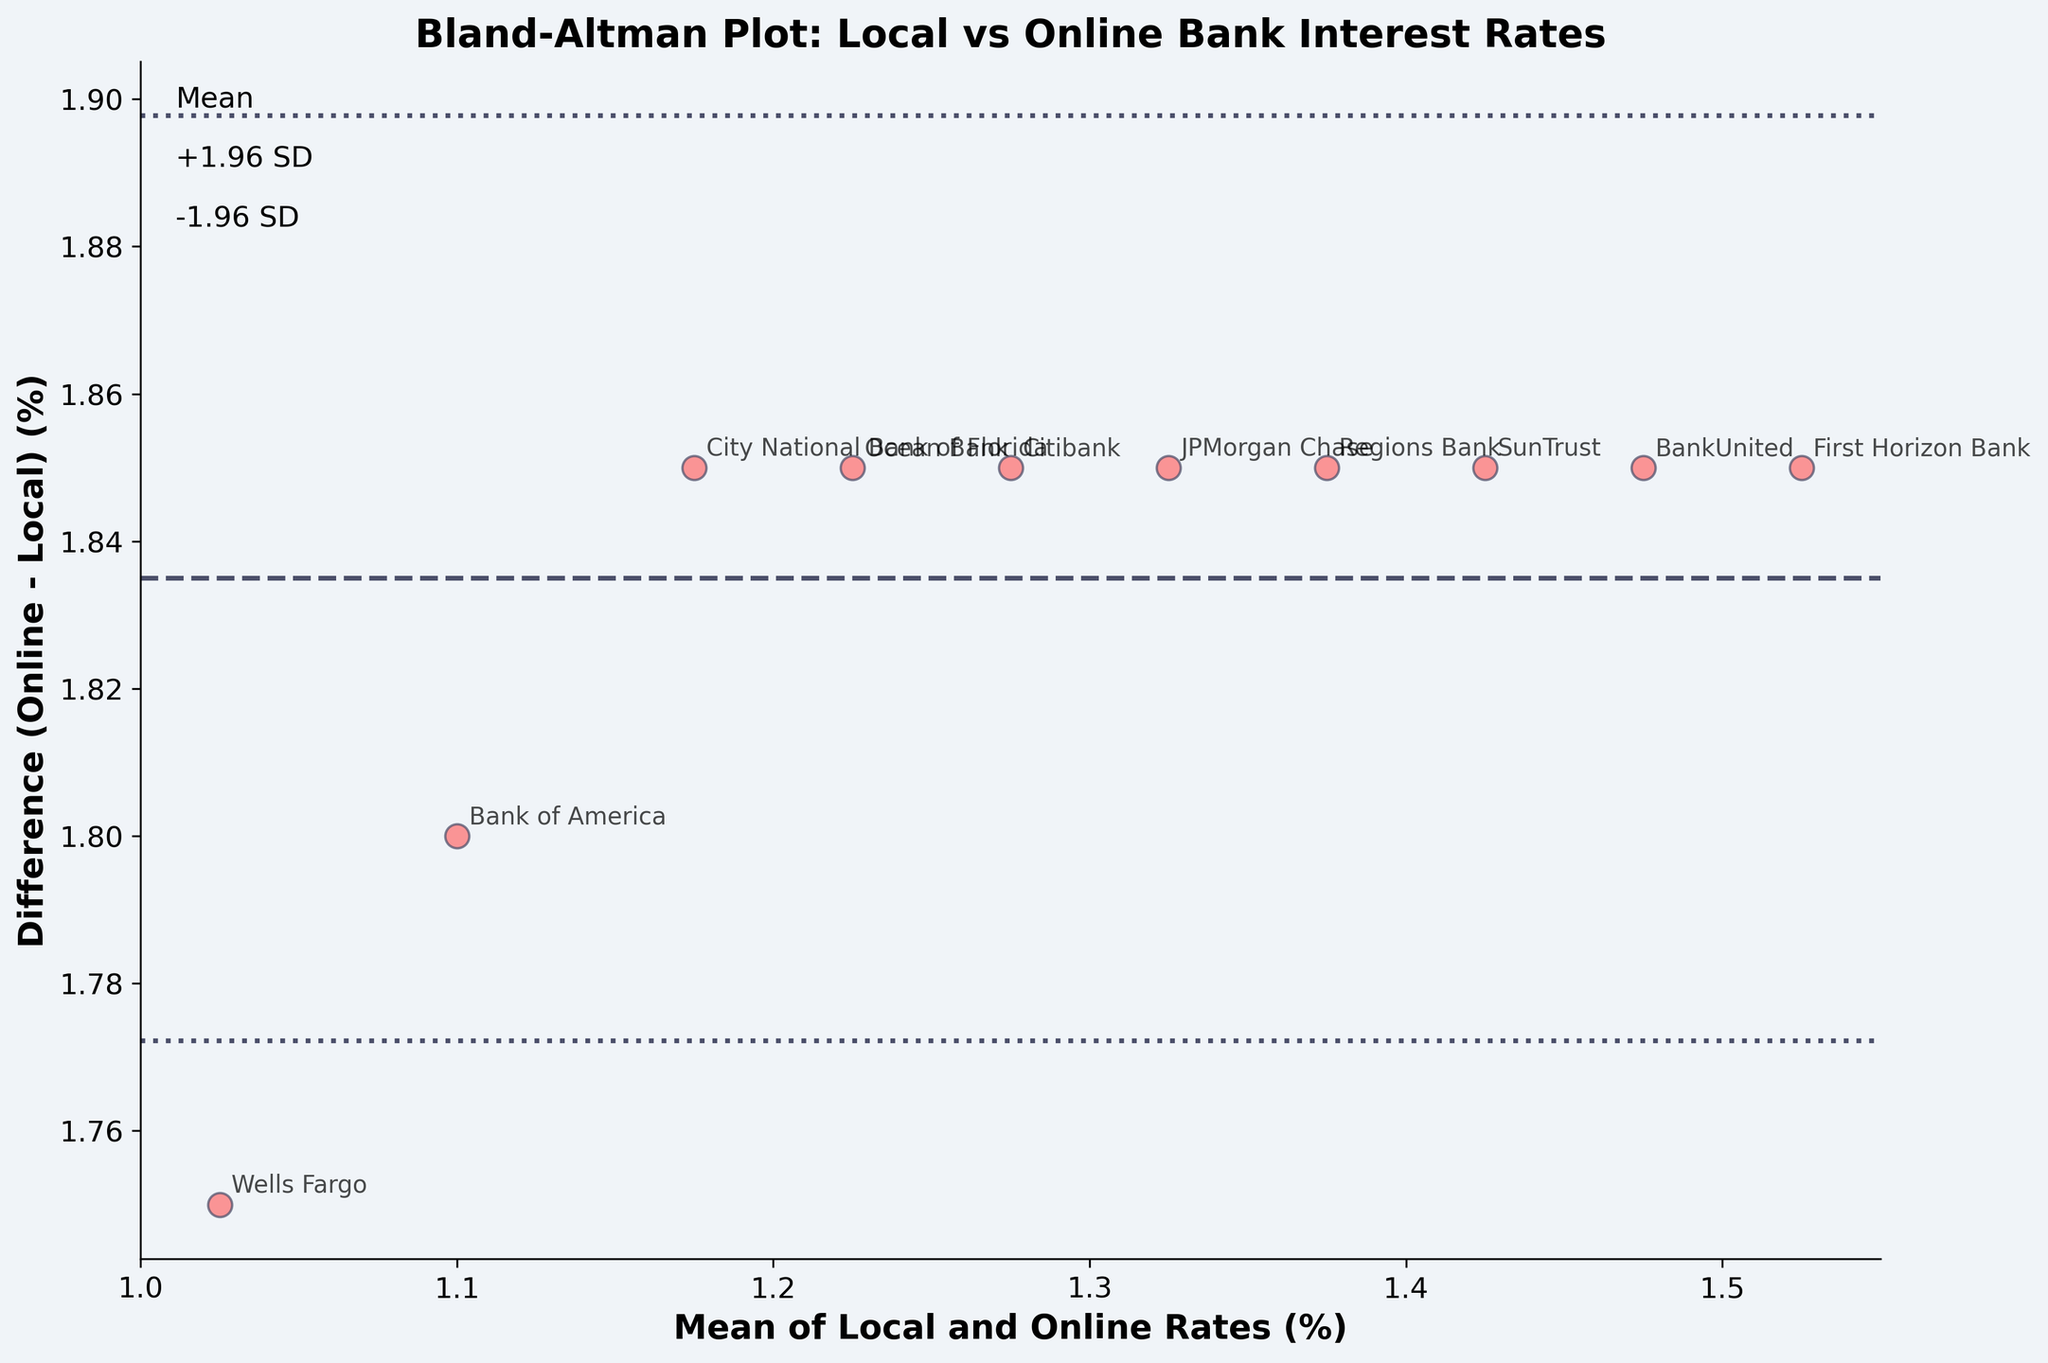What's the title of the plot? The title of the plot is located at the top center and generally gives a summary of what the plot is about.
Answer: Bland-Altman Plot: Local vs Online Bank Interest Rates How many banks are represented in the plot? Each point in the plot corresponds to one bank. By counting the points or data labels, we can determine the number of banks.
Answer: 10 What does the y-axis represent? The label on the y-axis typically explains what the axis measures. In this plot, it indicates the difference between online interest rates and local interest rates.
Answer: Difference (Online - Local) (%) What is the average difference between online and local rates? The average difference is indicated by the horizontal dashed line running through the plot, which represents the mean difference between the rates.
Answer: Approximately 1.9% Where does City National Bank of Florida fall on the plot in terms of the difference between its local and online rates? By locating the point labeled "City National Bank of Florida" in the plot, we can see its position on the y-axis, which tells us the difference between its online and local rates.
Answer: Approximately 1.85% Which bank has the greatest difference between its online and local rates? By identifying the point farthest from the dashed mean line on the y-axis, we can find the bank with the largest difference.
Answer: First Horizon Bank What are the mean and difference values for JPMorgan Chase? The position of JPMorgan Chase on the mean (x-axis) and difference (y-axis) can be identified to provide these values.
Answer: Mean: 1.325%, Difference: 1.85% Does any bank's interest rate difference fall outside the limits of agreement (+/- 1.96 SD)? Points outside the dotted lines, which represent the limits of agreement, will indicate whether any bank's rate difference falls outside these limits
Answer: No What is the spread of differences (Online - Local) in interest rates? The spread of differences can be observed by looking at the range between the highest and lowest difference values on the y-axis.
Answer: Approximately 2.3% to 1.85% Is the mean local interest rate generally lower or higher than the mean online interest rate? The mean line is above zero on the y-axis, indicating reviews of the differences, which all are positive, thus implying online rates are higher.
Answer: Lower 